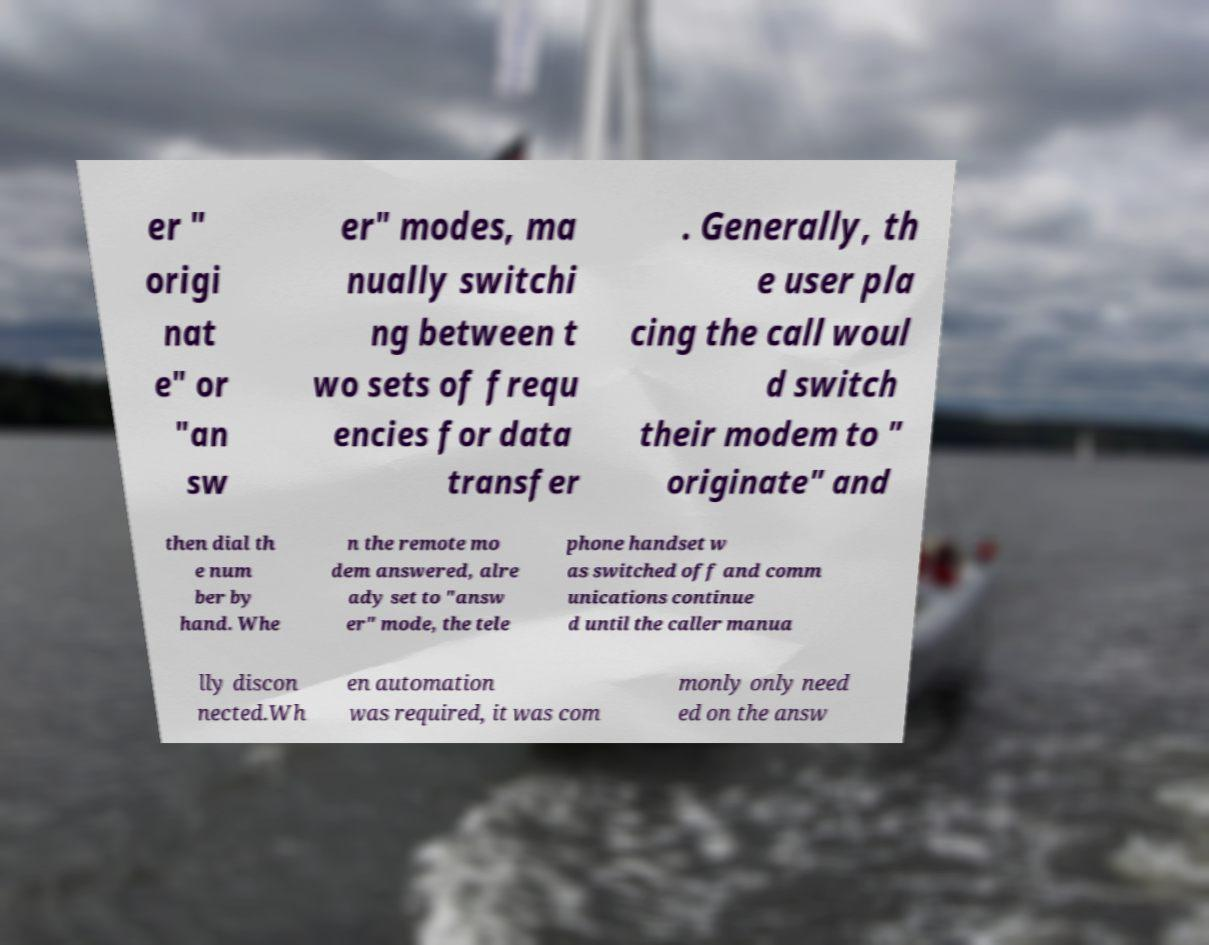Can you read and provide the text displayed in the image?This photo seems to have some interesting text. Can you extract and type it out for me? er " origi nat e" or "an sw er" modes, ma nually switchi ng between t wo sets of frequ encies for data transfer . Generally, th e user pla cing the call woul d switch their modem to " originate" and then dial th e num ber by hand. Whe n the remote mo dem answered, alre ady set to "answ er" mode, the tele phone handset w as switched off and comm unications continue d until the caller manua lly discon nected.Wh en automation was required, it was com monly only need ed on the answ 